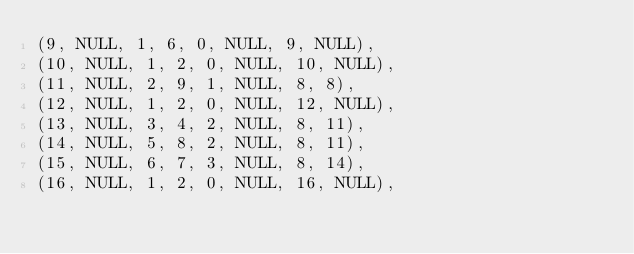Convert code to text. <code><loc_0><loc_0><loc_500><loc_500><_SQL_>(9, NULL, 1, 6, 0, NULL, 9, NULL),
(10, NULL, 1, 2, 0, NULL, 10, NULL),
(11, NULL, 2, 9, 1, NULL, 8, 8),
(12, NULL, 1, 2, 0, NULL, 12, NULL),
(13, NULL, 3, 4, 2, NULL, 8, 11),
(14, NULL, 5, 8, 2, NULL, 8, 11),
(15, NULL, 6, 7, 3, NULL, 8, 14),
(16, NULL, 1, 2, 0, NULL, 16, NULL),</code> 